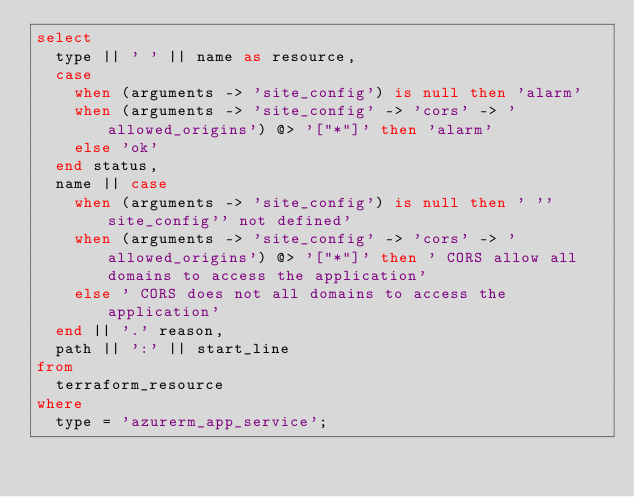Convert code to text. <code><loc_0><loc_0><loc_500><loc_500><_SQL_>select
  type || ' ' || name as resource,
  case
    when (arguments -> 'site_config') is null then 'alarm'
    when (arguments -> 'site_config' -> 'cors' -> 'allowed_origins') @> '["*"]' then 'alarm'
    else 'ok'
  end status,
  name || case
    when (arguments -> 'site_config') is null then ' ''site_config'' not defined'
    when (arguments -> 'site_config' -> 'cors' -> 'allowed_origins') @> '["*"]' then ' CORS allow all domains to access the application'
    else ' CORS does not all domains to access the application'
  end || '.' reason,
  path || ':' || start_line
from
  terraform_resource
where
  type = 'azurerm_app_service';</code> 